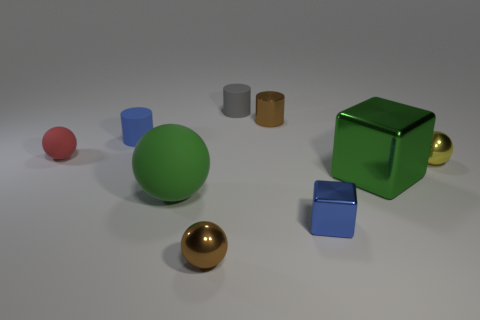Subtract all tiny matte balls. How many balls are left? 3 Add 1 small purple metal cubes. How many objects exist? 10 Subtract all green blocks. How many blocks are left? 1 Subtract 1 blocks. How many blocks are left? 1 Subtract all red cylinders. Subtract all brown balls. How many cylinders are left? 3 Subtract all yellow things. Subtract all yellow objects. How many objects are left? 7 Add 6 brown cylinders. How many brown cylinders are left? 7 Add 8 green spheres. How many green spheres exist? 9 Subtract 0 gray blocks. How many objects are left? 9 Subtract all cubes. How many objects are left? 7 